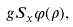Convert formula to latex. <formula><loc_0><loc_0><loc_500><loc_500>g S _ { x } \varphi ( \rho ) ,</formula> 